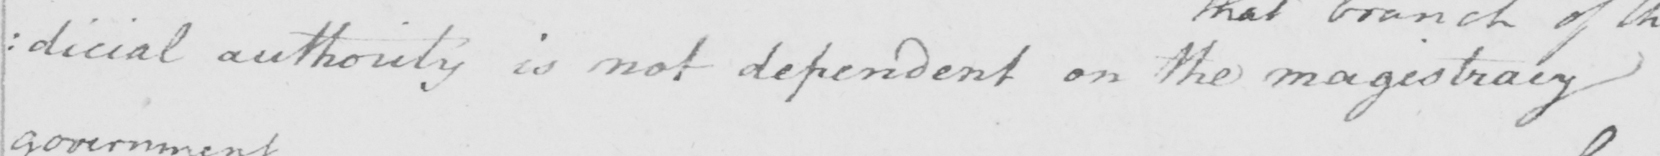What text is written in this handwritten line? : dicial authority is not dependent on the magistracy 